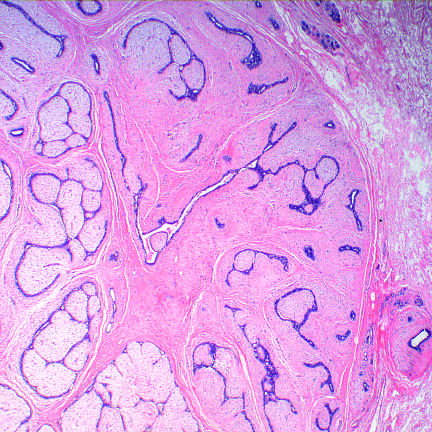what has an expansile growth pattern with pushing circumscribed borders?
Answer the question using a single word or phrase. This benign tumor 